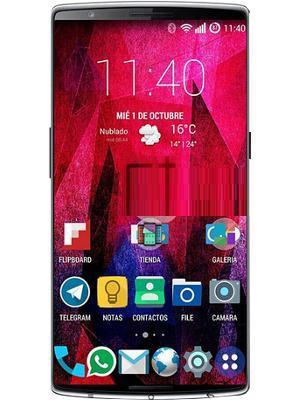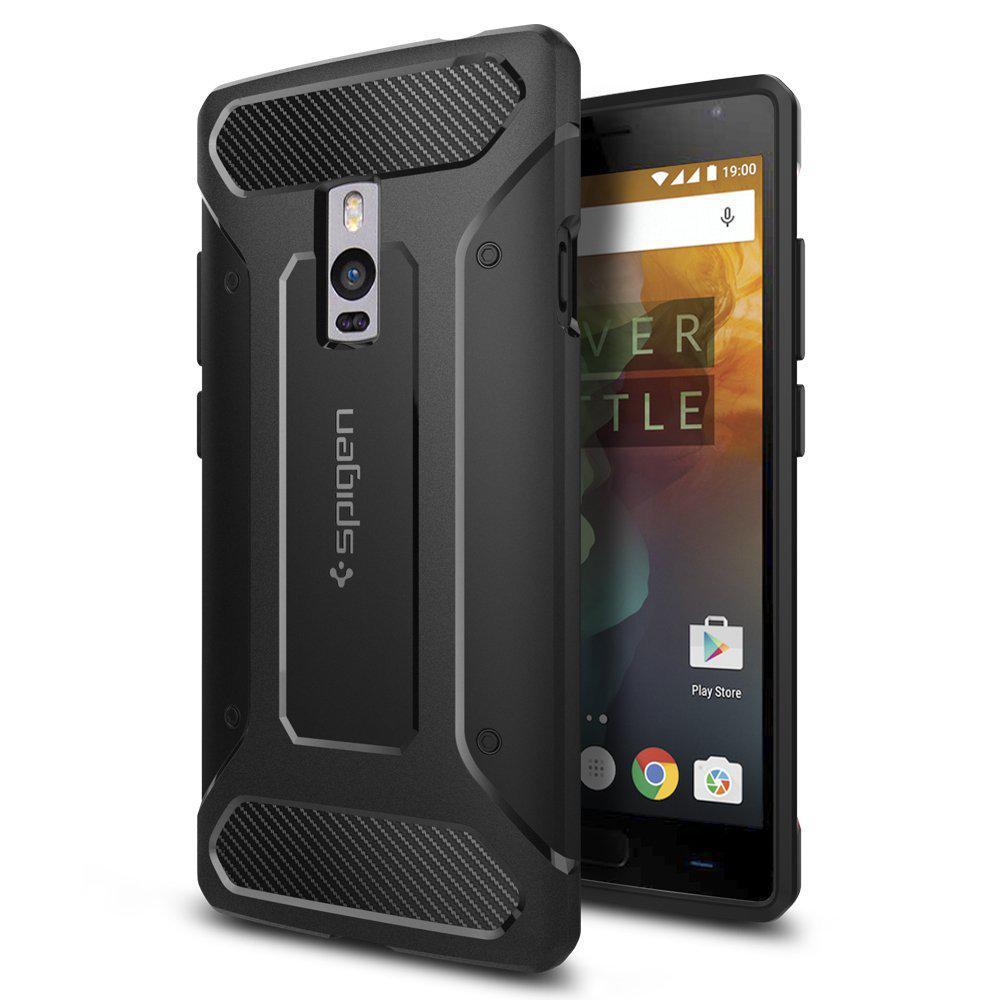The first image is the image on the left, the second image is the image on the right. Considering the images on both sides, is "At least one image features the side profile of a phone." valid? Answer yes or no. No. The first image is the image on the left, the second image is the image on the right. For the images displayed, is the sentence "The right image shows, in head-on view, a stylus to the right of a solid-colored device overlapped by the same shape with a screen on it." factually correct? Answer yes or no. No. 